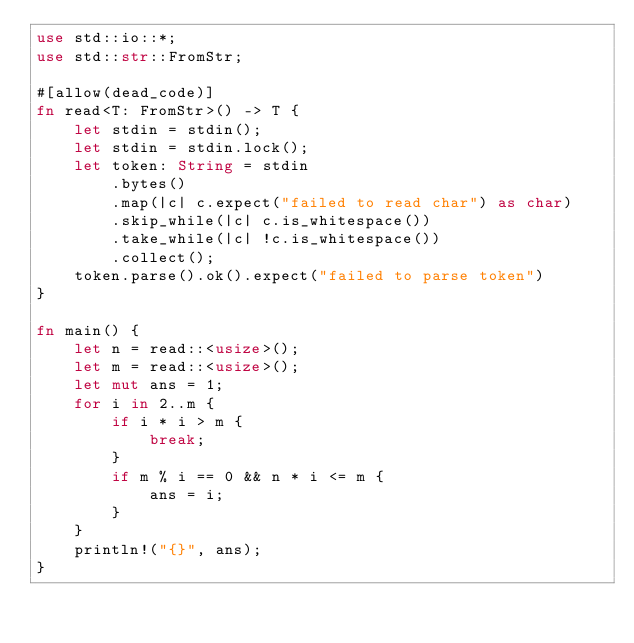<code> <loc_0><loc_0><loc_500><loc_500><_Rust_>use std::io::*;
use std::str::FromStr;

#[allow(dead_code)]
fn read<T: FromStr>() -> T {
    let stdin = stdin();
    let stdin = stdin.lock();
    let token: String = stdin
        .bytes()
        .map(|c| c.expect("failed to read char") as char)
        .skip_while(|c| c.is_whitespace())
        .take_while(|c| !c.is_whitespace())
        .collect();
    token.parse().ok().expect("failed to parse token")
}

fn main() {
    let n = read::<usize>();
    let m = read::<usize>();
    let mut ans = 1;
    for i in 2..m {
        if i * i > m {
            break;
        }
        if m % i == 0 && n * i <= m {
            ans = i;
        }
    }
    println!("{}", ans);
}
</code> 